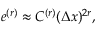<formula> <loc_0><loc_0><loc_500><loc_500>e ^ { ( r ) } \approx C ^ { ( r ) } ( \Delta x ) ^ { 2 r } ,</formula> 